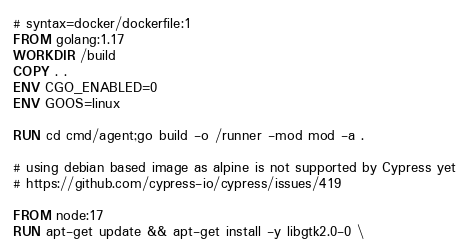<code> <loc_0><loc_0><loc_500><loc_500><_Dockerfile_># syntax=docker/dockerfile:1
FROM golang:1.17
WORKDIR /build
COPY . .
ENV CGO_ENABLED=0 
ENV GOOS=linux

RUN cd cmd/agent;go build -o /runner -mod mod -a .

# using debian based image as alpine is not supported by Cypress yet
# https://github.com/cypress-io/cypress/issues/419 

FROM node:17
RUN apt-get update && apt-get install -y libgtk2.0-0 \</code> 